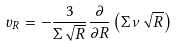Convert formula to latex. <formula><loc_0><loc_0><loc_500><loc_500>v _ { R } = - \frac { 3 } { \Sigma \sqrt { R } } \frac { \partial } { \partial R } \left ( \Sigma \nu \sqrt { R } \right )</formula> 